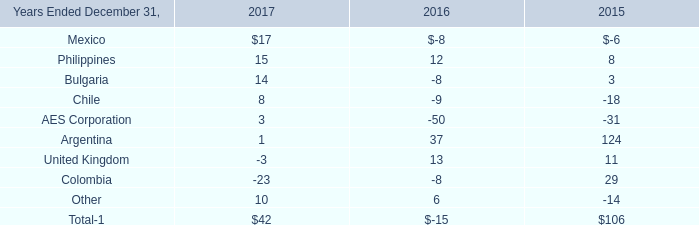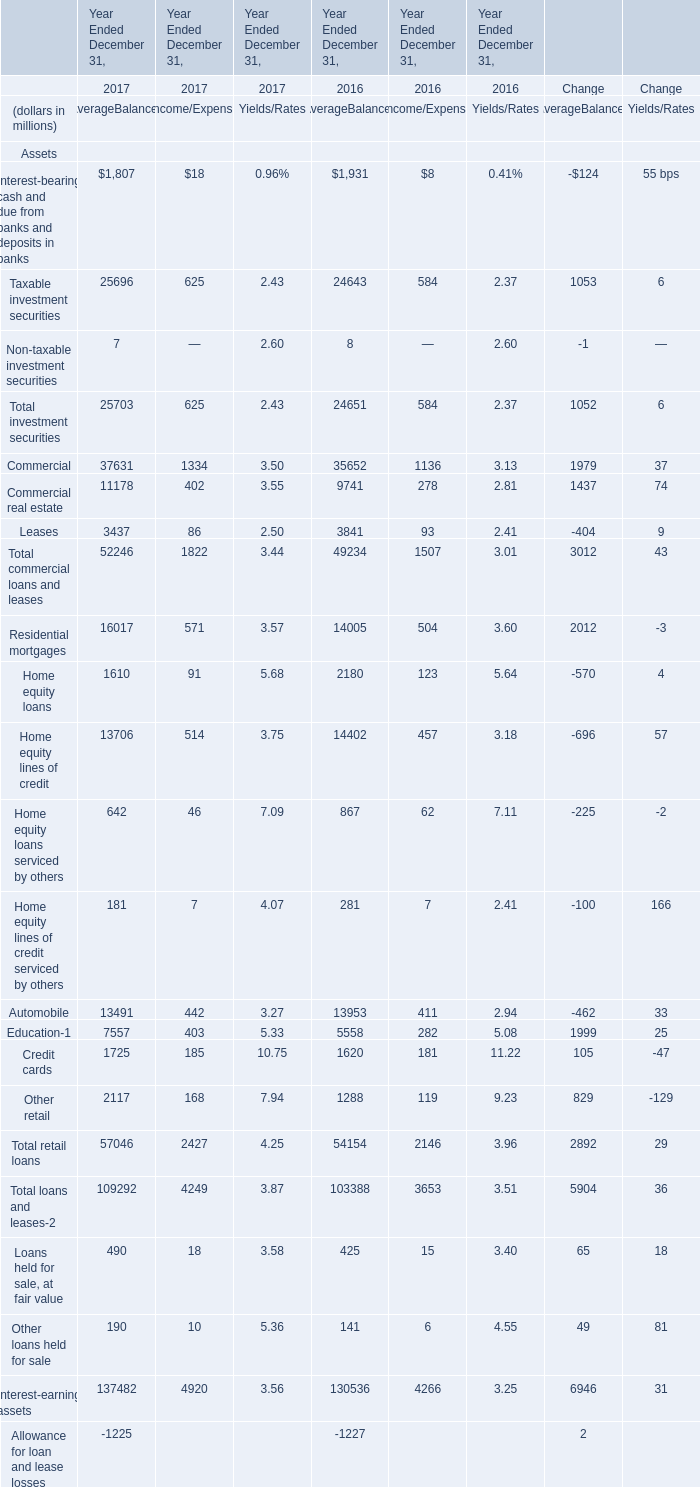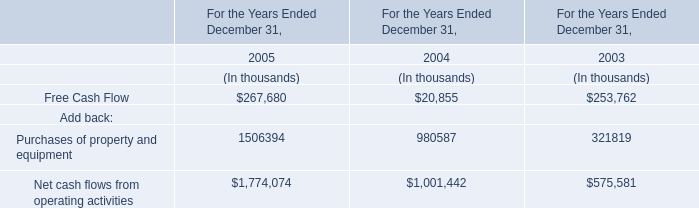Does the value of Taxable investment securities for AverageBalances in 2016 greater than that in 2017? 
Answer: No. 